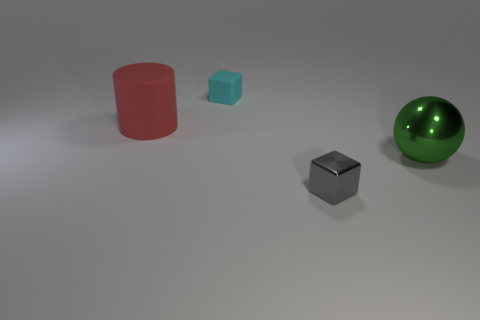There is a red matte object to the left of the small block that is in front of the big thing to the right of the small gray thing; what size is it?
Give a very brief answer. Large. Is the number of large rubber things that are on the left side of the large red matte cylinder greater than the number of green metal things to the right of the tiny cyan rubber cube?
Offer a terse response. No. What number of shiny spheres are right of the small object that is to the right of the tiny matte object?
Your answer should be very brief. 1. Is there a metallic cube that has the same color as the large matte thing?
Offer a terse response. No. Is the size of the metal block the same as the cylinder?
Your answer should be very brief. No. Is the small matte thing the same color as the big matte cylinder?
Give a very brief answer. No. What is the material of the cube that is in front of the metallic object that is behind the small gray metallic object?
Your response must be concise. Metal. There is another tiny object that is the same shape as the cyan object; what is its material?
Your answer should be compact. Metal. There is a metallic object behind the gray cube; does it have the same size as the gray thing?
Ensure brevity in your answer.  No. How many metallic things are large green things or small gray blocks?
Offer a terse response. 2. 